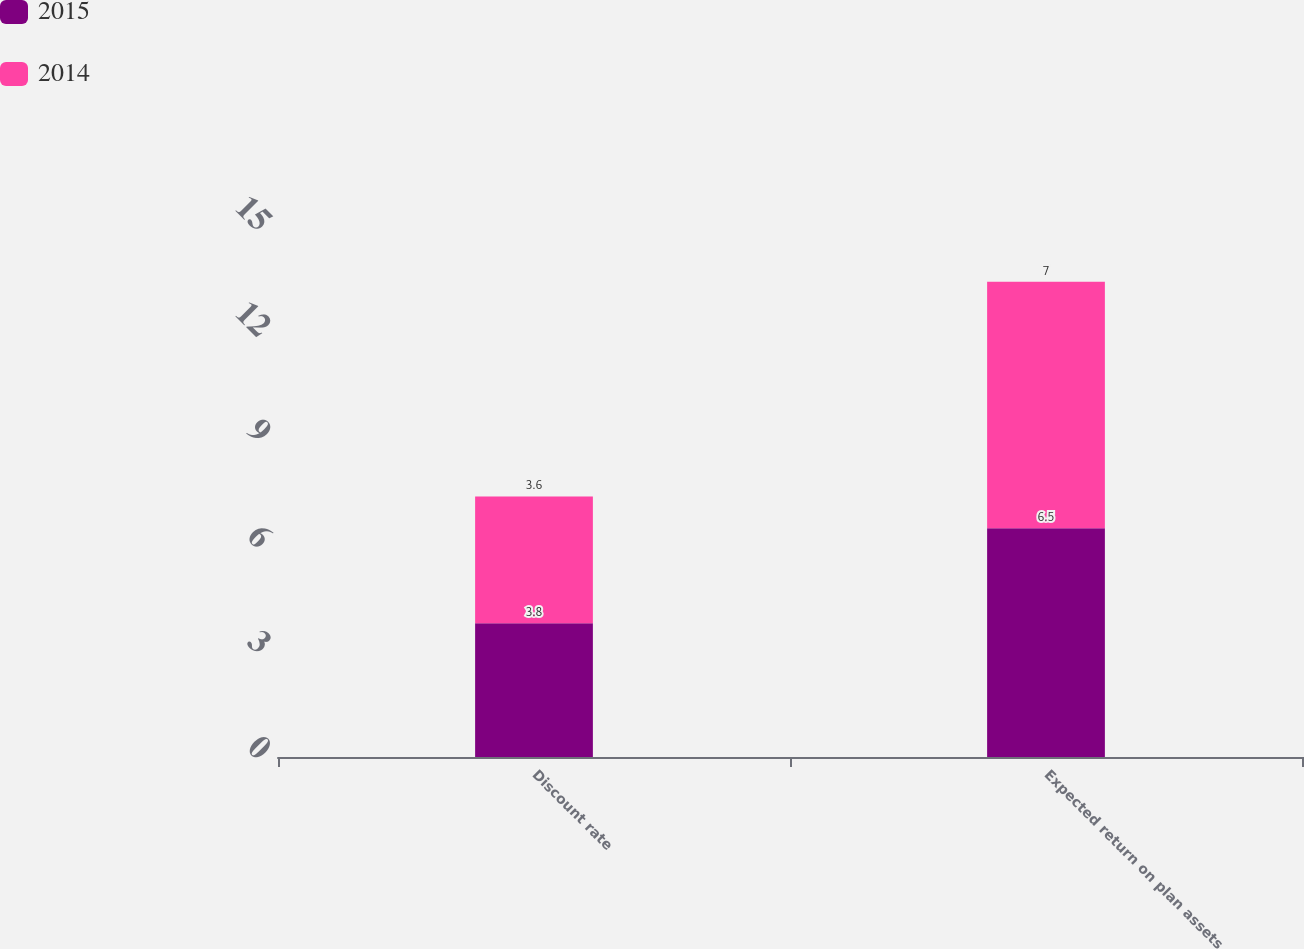Convert chart. <chart><loc_0><loc_0><loc_500><loc_500><stacked_bar_chart><ecel><fcel>Discount rate<fcel>Expected return on plan assets<nl><fcel>2015<fcel>3.8<fcel>6.5<nl><fcel>2014<fcel>3.6<fcel>7<nl></chart> 